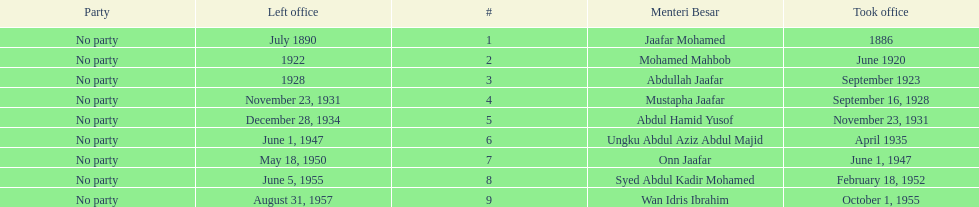Who was in office previous to abdullah jaafar? Mohamed Mahbob. 